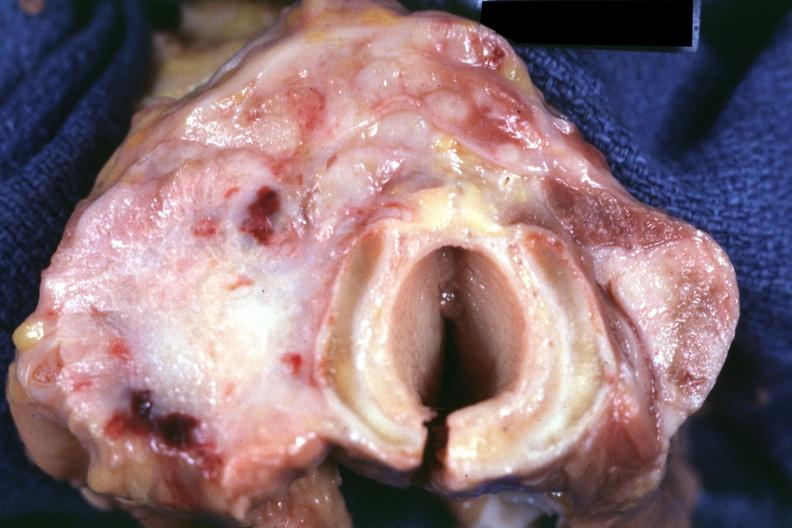s 70yof had colon carcinoma?
Answer the question using a single word or phrase. Yes 